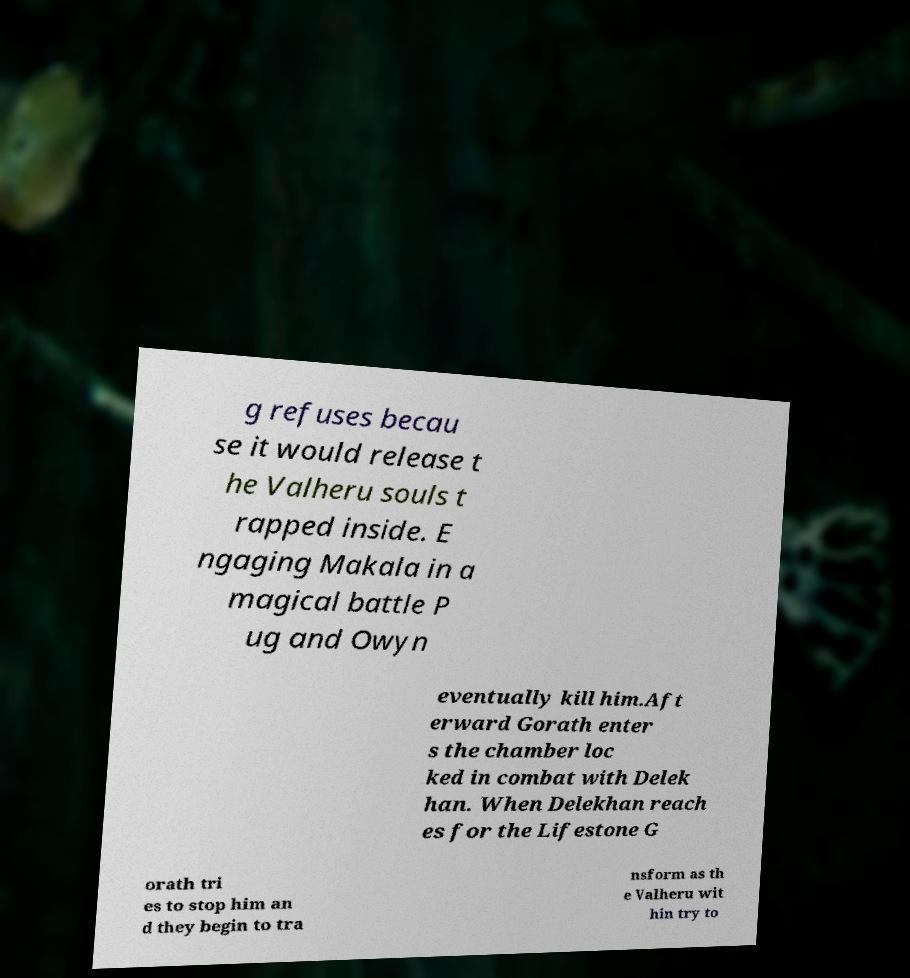I need the written content from this picture converted into text. Can you do that? g refuses becau se it would release t he Valheru souls t rapped inside. E ngaging Makala in a magical battle P ug and Owyn eventually kill him.Aft erward Gorath enter s the chamber loc ked in combat with Delek han. When Delekhan reach es for the Lifestone G orath tri es to stop him an d they begin to tra nsform as th e Valheru wit hin try to 